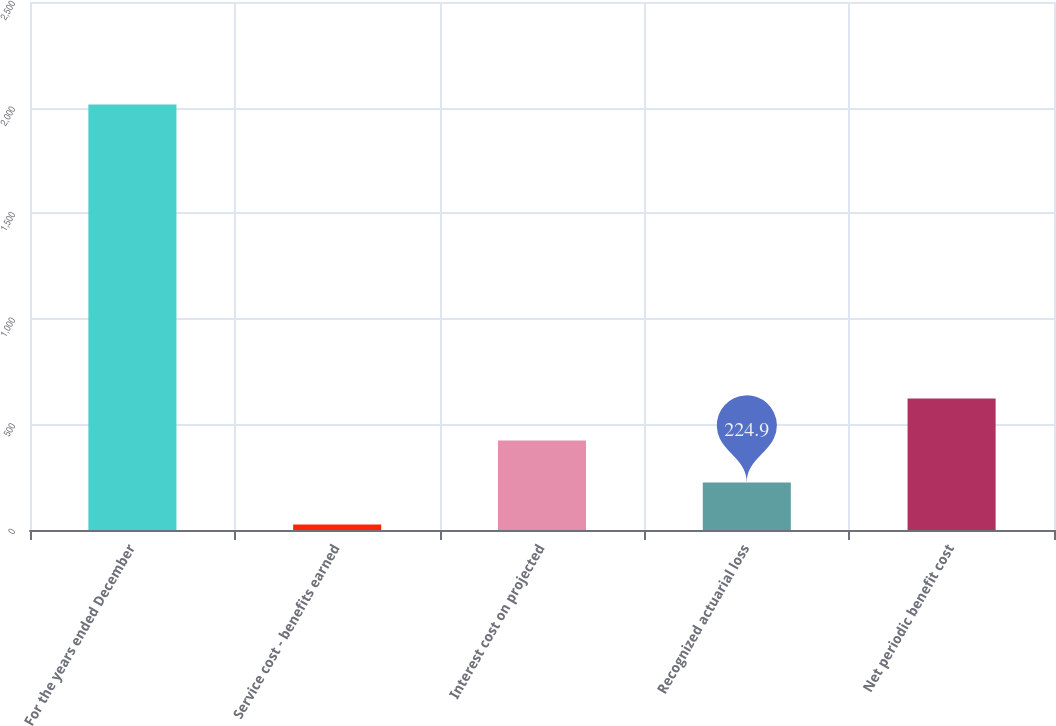Convert chart to OTSL. <chart><loc_0><loc_0><loc_500><loc_500><bar_chart><fcel>For the years ended December<fcel>Service cost - benefits earned<fcel>Interest cost on projected<fcel>Recognized actuarial loss<fcel>Net periodic benefit cost<nl><fcel>2015<fcel>26<fcel>423.8<fcel>224.9<fcel>622.7<nl></chart> 